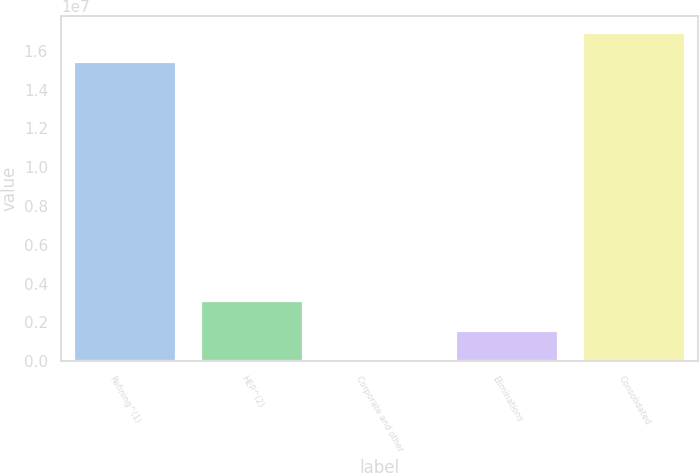<chart> <loc_0><loc_0><loc_500><loc_500><bar_chart><fcel>Refining^(1)<fcel>HEP^(2)<fcel>Corporate and other<fcel>Eliminations<fcel>Consolidated<nl><fcel>1.53924e+07<fcel>3.0889e+06<fcel>1247<fcel>1.54508e+06<fcel>1.69363e+07<nl></chart> 